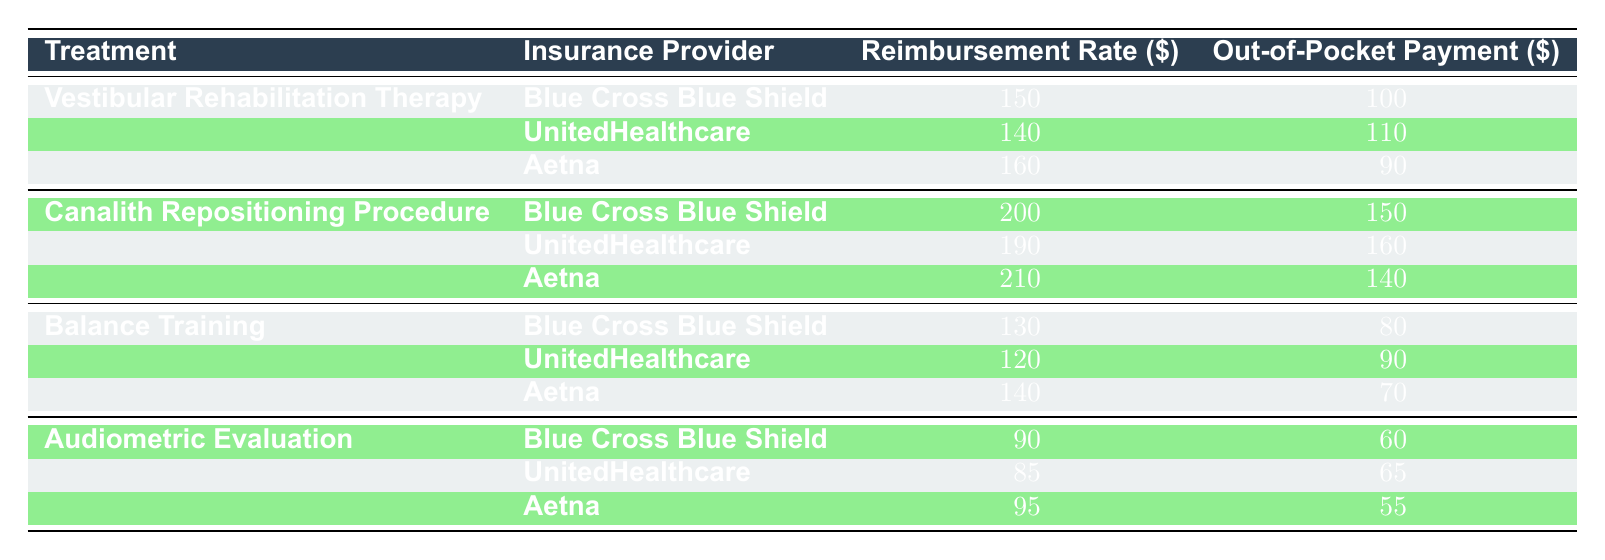What is the highest reimbursement rate for a treatment listed in the table? The highest reimbursement rate can be identified by scanning through the Reimbursement Rate column. The highest value is 210, which corresponds to the Canalith Repositioning Procedure under Aetna.
Answer: 210 Which treatment has the lowest out-of-pocket payment according to this table? To find the lowest out-of-pocket payment, we look through the Out-of-Pocket Payment column. The lowest value is 55, which is for the Audiometric Evaluation under Aetna.
Answer: 55 What is the average reimbursement rate for Vestibular Rehabilitation Therapy across the three insurance providers? We first sum the reimbursement rates for Vestibular Rehabilitation Therapy: 150 (Blue Cross Blue Shield) + 140 (UnitedHealthcare) + 160 (Aetna) = 450. Then, we divide by the number of insurance providers (3): 450 / 3 = 150.
Answer: 150 Is there a treatment that has a higher out-of-pocket payment with UnitedHealthcare than with Aetna? We check the Out-of-Pocket Payment for both insurance providers and treatments. UnitedHealthcare's payment for the Canalith Repositioning Procedure is 160, while Aetna's payment for the same treatment is 140. Since 160 is higher, the statement is true.
Answer: Yes What is the total reimbursement amount for Balance Training among all insurance providers? We sum the reimbursement rates for Balance Training: 130 (Blue Cross Blue Shield) + 120 (UnitedHealthcare) + 140 (Aetna) = 390. Therefore, the total reimbursement amount is 390.
Answer: 390 Does Blue Cross Blue Shield have the highest reimbursement rate for any treatment? We compare the reimbursement rates for Blue Cross Blue Shield with those of other providers for each treatment. It turns out that for the Canalith Repositioning Procedure, Blue Cross Blue Shield has the highest rate at 200, so the answer is yes.
Answer: Yes What is the difference in out-of-pocket payment between Canalith Repositioning Procedure with Blue Cross Blue Shield and Balance Training with Aetna? We first take the out-of-pocket payment for Canalith Repositioning Procedure under Blue Cross Blue Shield, which is 150, and for Balance Training under Aetna, which is 70. Calculating the difference: 150 - 70 = 80.
Answer: 80 Which insurance provider offers the lowest reimbursement for Audiometric Evaluation? We examine the reimbursement rates for Audiometric Evaluation across all three providers: Blue Cross Blue Shield has 90, UnitedHealthcare has 85, and Aetna offers 95. The lowest is from UnitedHealthcare at 85.
Answer: 85 